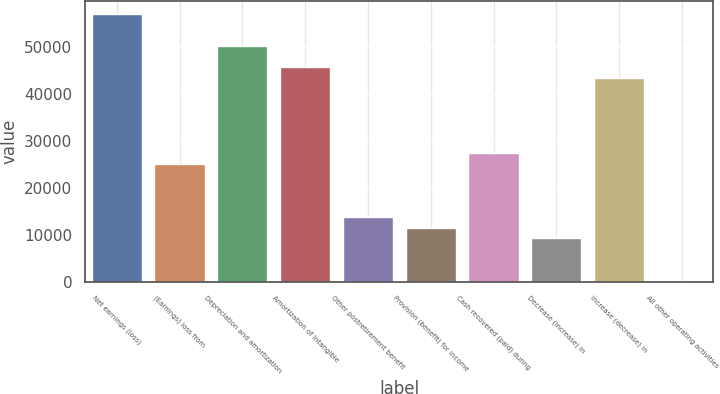<chart> <loc_0><loc_0><loc_500><loc_500><bar_chart><fcel>Net earnings (loss)<fcel>(Earnings) loss from<fcel>Depreciation and amortization<fcel>Amortization of intangible<fcel>Other postretirement benefit<fcel>Provision (benefit) for income<fcel>Cash recovered (paid) during<fcel>Decrease (increase) in<fcel>Increase (decrease) in<fcel>All other operating activities<nl><fcel>57140<fcel>25211.6<fcel>50298.2<fcel>45737<fcel>13808.6<fcel>11528<fcel>27492.2<fcel>9247.4<fcel>43456.4<fcel>125<nl></chart> 